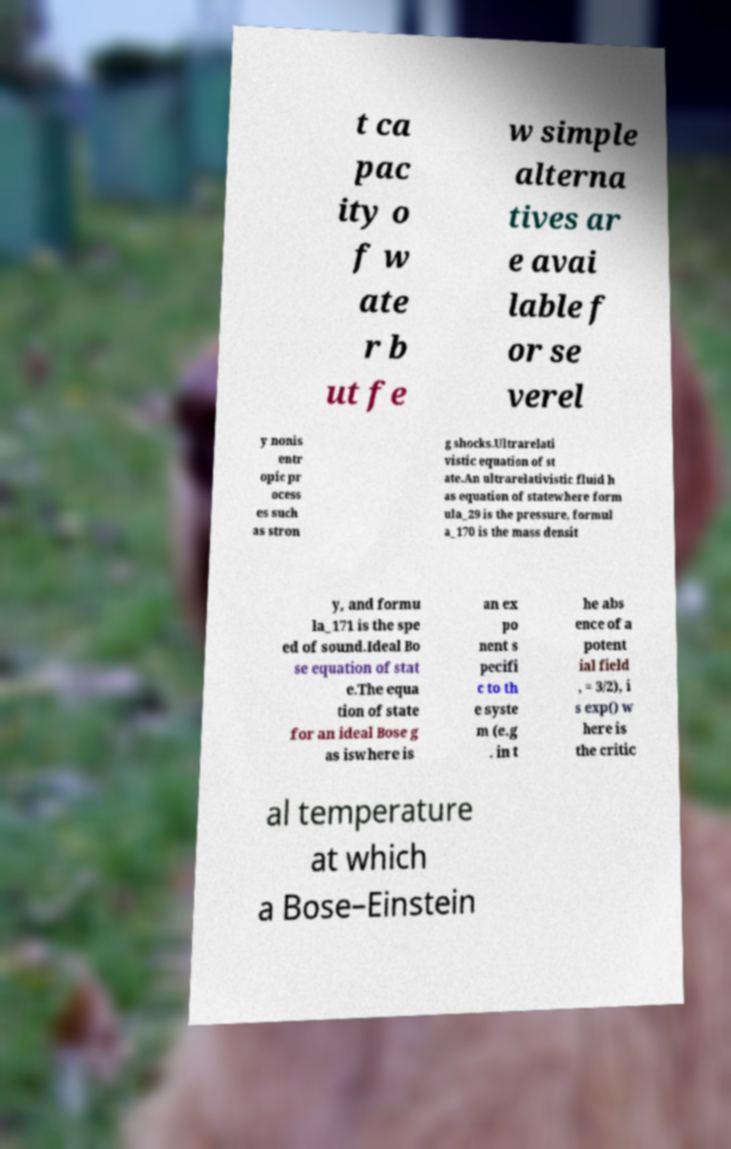I need the written content from this picture converted into text. Can you do that? t ca pac ity o f w ate r b ut fe w simple alterna tives ar e avai lable f or se verel y nonis entr opic pr ocess es such as stron g shocks.Ultrarelati vistic equation of st ate.An ultrarelativistic fluid h as equation of statewhere form ula_29 is the pressure, formul a_170 is the mass densit y, and formu la_171 is the spe ed of sound.Ideal Bo se equation of stat e.The equa tion of state for an ideal Bose g as iswhere is an ex po nent s pecifi c to th e syste m (e.g . in t he abs ence of a potent ial field , = 3/2), i s exp() w here is the critic al temperature at which a Bose–Einstein 